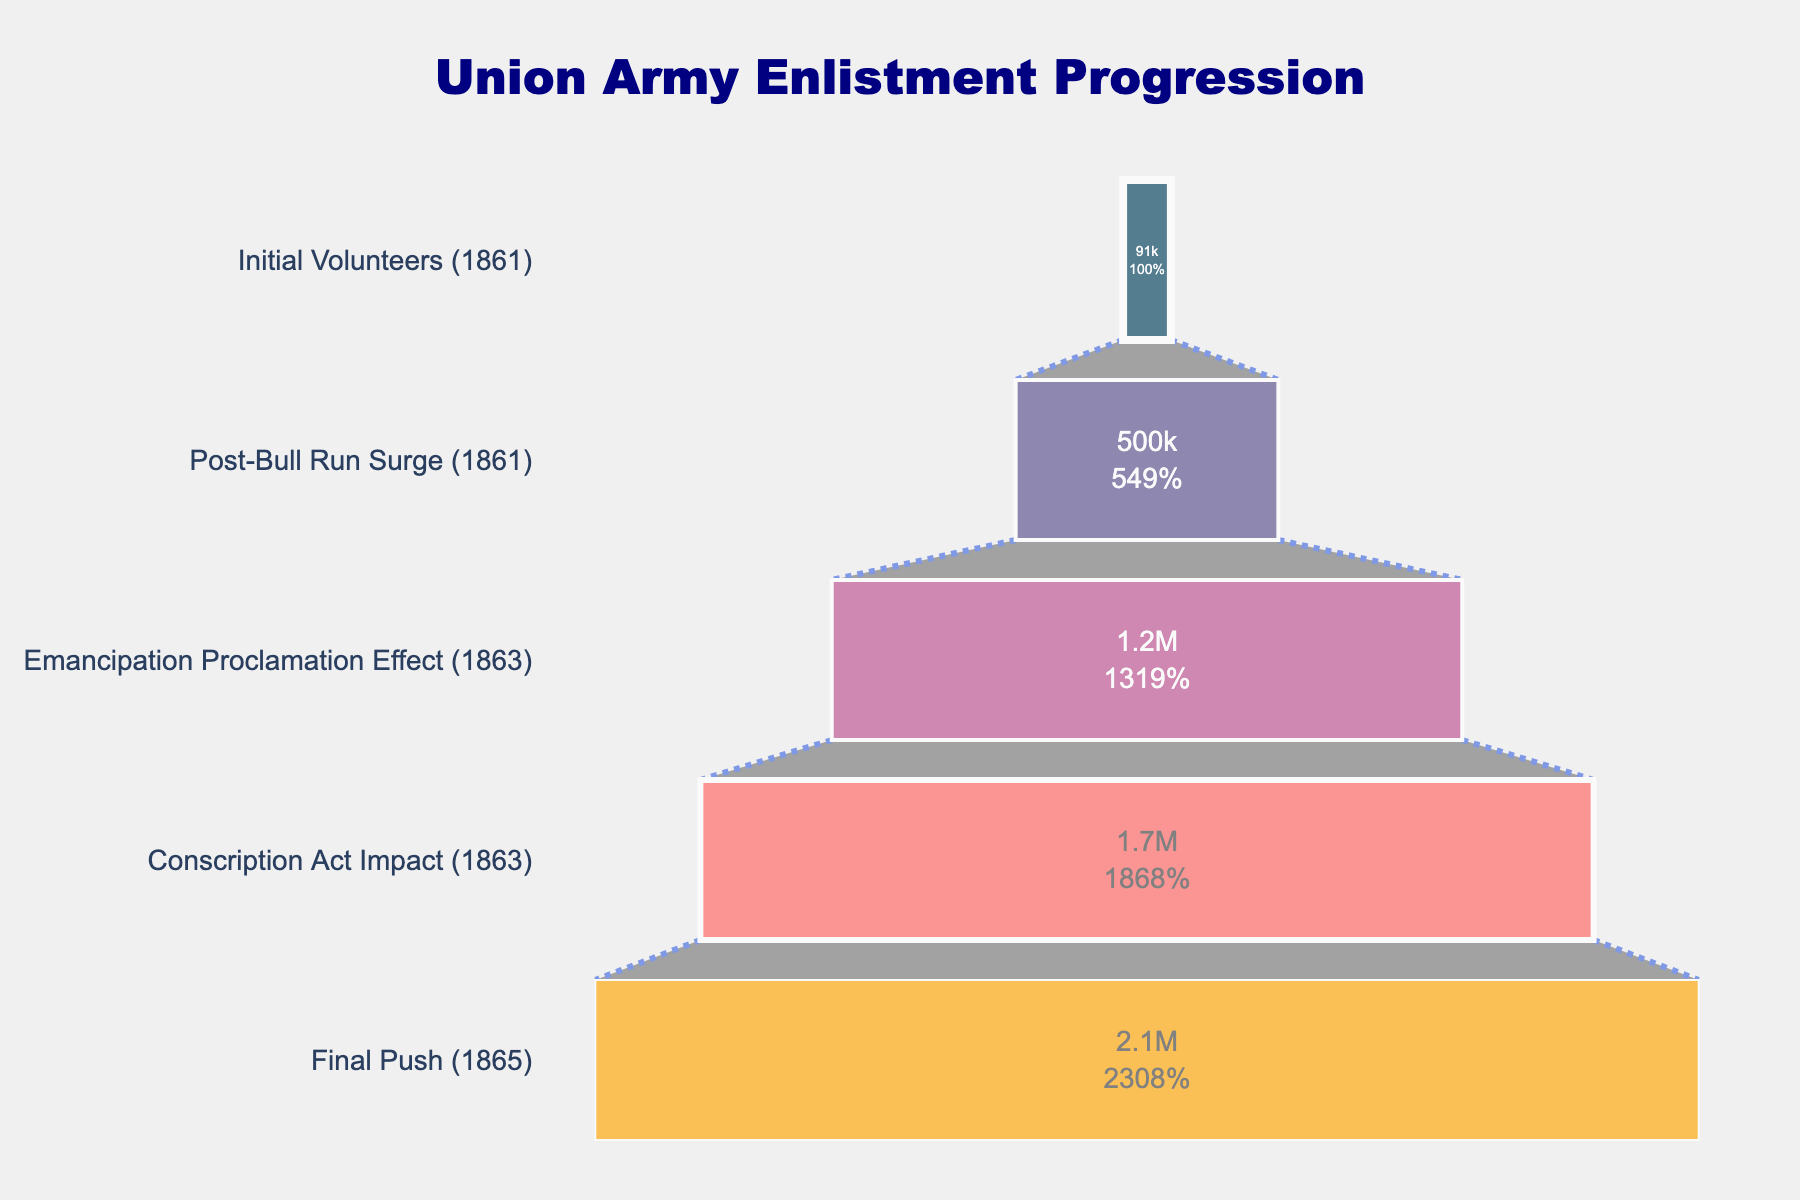What is the title of the funnel chart? The title is prominently displayed at the top of the chart, and is in a larger font size and bolded.
Answer: Union Army Enlistment Progression What stage of enlistment had the most significant impact? The chart shows the number of enlistments for each stage, with the largest number indicating the most significant impact. The stage with the highest enlistment number is the "Final Push (1865)" with 2,100,000 enlistments.
Answer: Final Push (1865) Which stage had the least enlistment numbers? By looking at the first segment of the funnel, the smallest number of enlistments is seen. The initial volunteers in 1861 had the least number of enlistments at 91,000.
Answer: Initial Volunteers (1861) How many more enlistments were there during the "Emancipation Proclamation Effect (1863)" compared to the "Initial Volunteers (1861)" stage? Calculate the difference by subtracting the number of enlistments in the "Initial Volunteers (1861)" from the "Emancipation Proclamation Effect (1863)". 1,200,000 - 91,000 = 1,109,000.
Answer: 1,109,000 What percentage of the initial enlistment number was achieved during the "Conscription Act Impact (1863)"? The chart provides enlistment numbers and their percentages of the initial stage. The percentage for "Conscription Act Impact (1863)" can be read directly.
Answer: 1870% How did the enlistment numbers change between the "Post-Bull Run Surge (1861)" and the "Emancipation Proclamation Effect (1863)"? Observe the change in enlistment numbers between these two stages using subtraction. 1,200,000 - 500,000 = 700,000. The enlistment numbers increased by 700,000.
Answer: Increased by 700,000 What were the enlistment numbers for the "Conscription Act Impact (1863)" stage? The enlistment numbers for each stage are clearly marked inside each segment of the funnel chart. The number for the "Conscription Act Impact (1863)" stage is 1,700,000.
Answer: 1,700,000 What is the order of stages from the highest to the lowest enlistment numbers? The stages can be ranked by comparing the enlistment numbers displayed within each segment: "Final Push (1865)" > "Conscription Act Impact (1863)" > "Emancipation Proclamation Effect (1863)" > "Post-Bull Run Surge (1861)" > "Initial Volunteers (1861)".
Answer: Final Push (1865), Conscription Act Impact (1863), Emancipation Proclamation Effect (1863), Post-Bull Run Surge (1861), Initial Volunteers (1861) What is the overall trend observed in the enlistment numbers throughout the stages? The chart shows a general increase in enlistment numbers as the stages progress through the war years, indicating a continual rise in recruitment and conscription efforts.
Answer: Increasing trend 